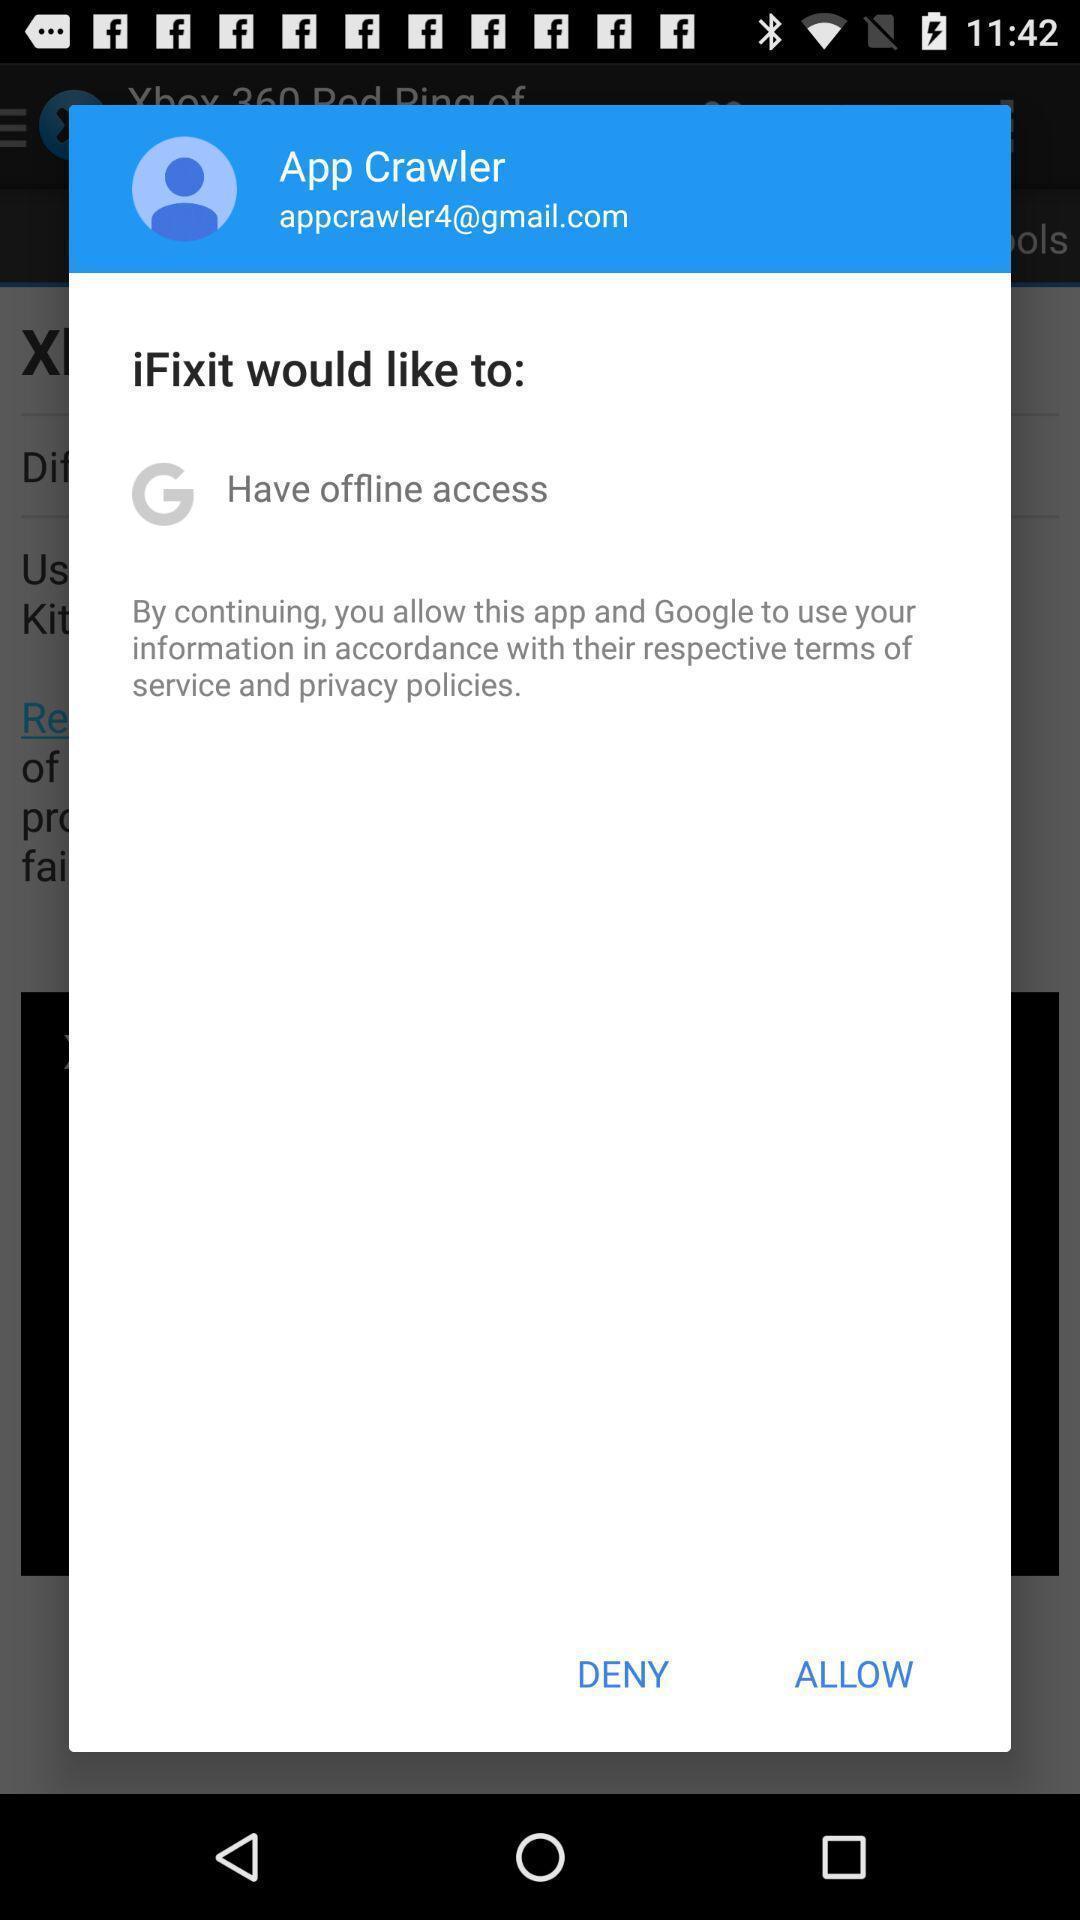Provide a description of this screenshot. Pop-up window showing a message to give access. 